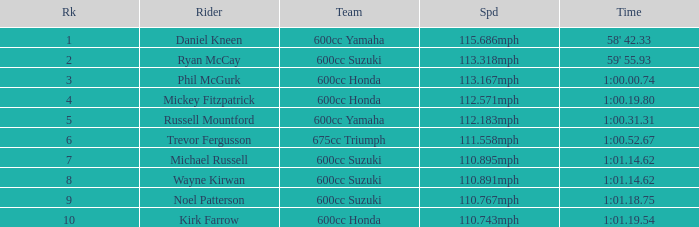What time has phil mcgurk as the rider? 1:00.00.74. 